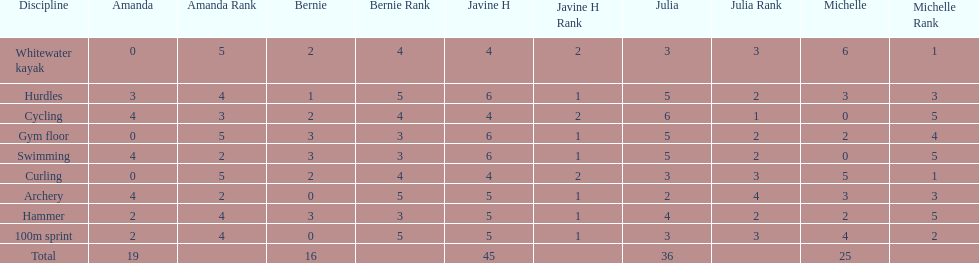Which of the girls had the least amount in archery? Bernie. 